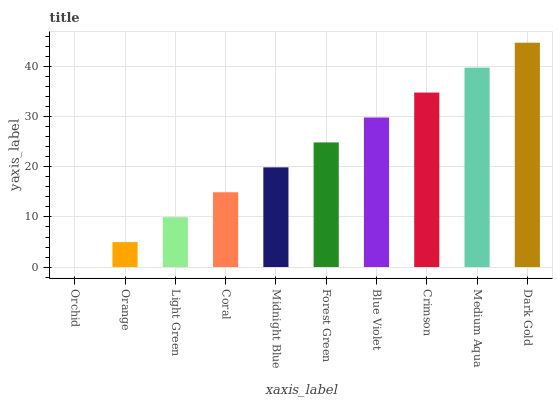Is Orchid the minimum?
Answer yes or no. Yes. Is Dark Gold the maximum?
Answer yes or no. Yes. Is Orange the minimum?
Answer yes or no. No. Is Orange the maximum?
Answer yes or no. No. Is Orange greater than Orchid?
Answer yes or no. Yes. Is Orchid less than Orange?
Answer yes or no. Yes. Is Orchid greater than Orange?
Answer yes or no. No. Is Orange less than Orchid?
Answer yes or no. No. Is Forest Green the high median?
Answer yes or no. Yes. Is Midnight Blue the low median?
Answer yes or no. Yes. Is Crimson the high median?
Answer yes or no. No. Is Forest Green the low median?
Answer yes or no. No. 